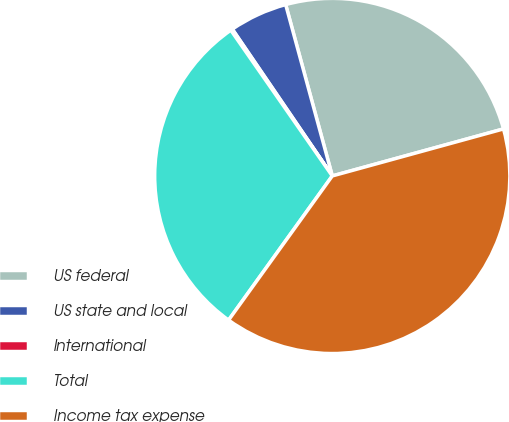Convert chart to OTSL. <chart><loc_0><loc_0><loc_500><loc_500><pie_chart><fcel>US federal<fcel>US state and local<fcel>International<fcel>Total<fcel>Income tax expense<nl><fcel>24.96%<fcel>5.29%<fcel>0.16%<fcel>30.4%<fcel>39.19%<nl></chart> 